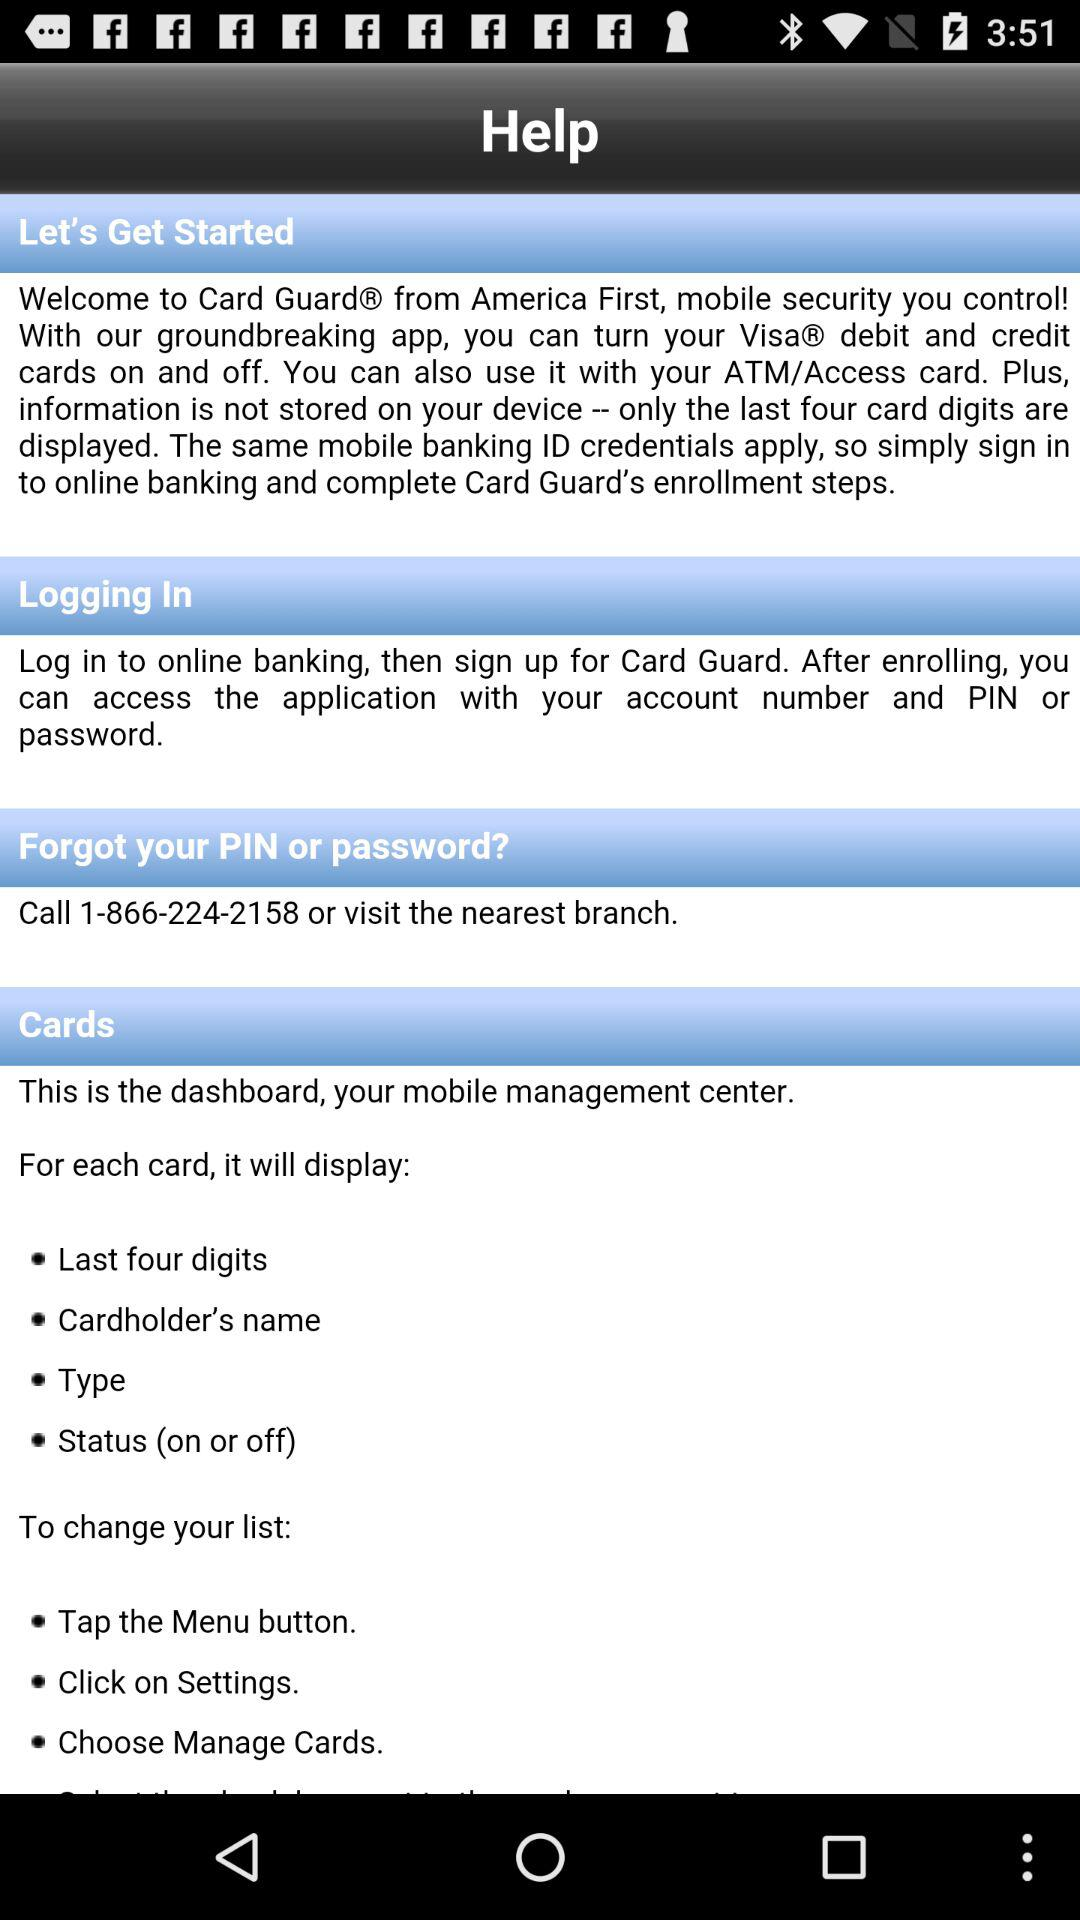Whom should we contact in case we forget our PIN or password? You should call 1-866-224-2158 or visit the nearest branch in case we forget our PIN or password. 